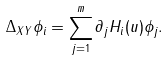Convert formula to latex. <formula><loc_0><loc_0><loc_500><loc_500>\Delta _ { X Y } \phi _ { i } = \sum _ { j = 1 } ^ { m } \partial _ { j } H _ { i } ( u ) \phi _ { j } .</formula> 